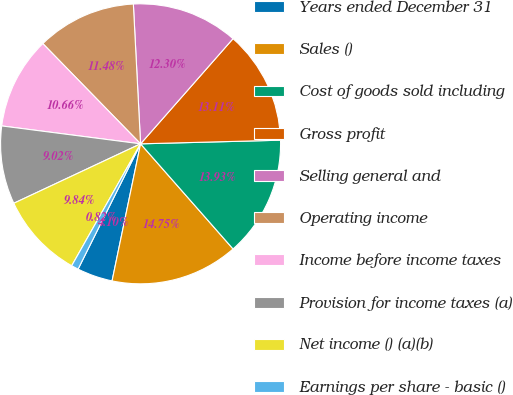Convert chart to OTSL. <chart><loc_0><loc_0><loc_500><loc_500><pie_chart><fcel>Years ended December 31<fcel>Sales ()<fcel>Cost of goods sold including<fcel>Gross profit<fcel>Selling general and<fcel>Operating income<fcel>Income before income taxes<fcel>Provision for income taxes (a)<fcel>Net income () (a)(b)<fcel>Earnings per share - basic ()<nl><fcel>4.1%<fcel>14.75%<fcel>13.93%<fcel>13.11%<fcel>12.3%<fcel>11.48%<fcel>10.66%<fcel>9.02%<fcel>9.84%<fcel>0.82%<nl></chart> 